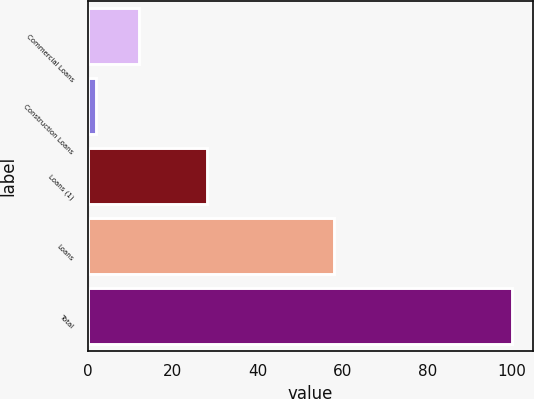Convert chart to OTSL. <chart><loc_0><loc_0><loc_500><loc_500><bar_chart><fcel>Commercial Loans<fcel>Construction Loans<fcel>Loans (1)<fcel>Loans<fcel>Total<nl><fcel>12<fcel>2<fcel>28<fcel>58<fcel>100<nl></chart> 